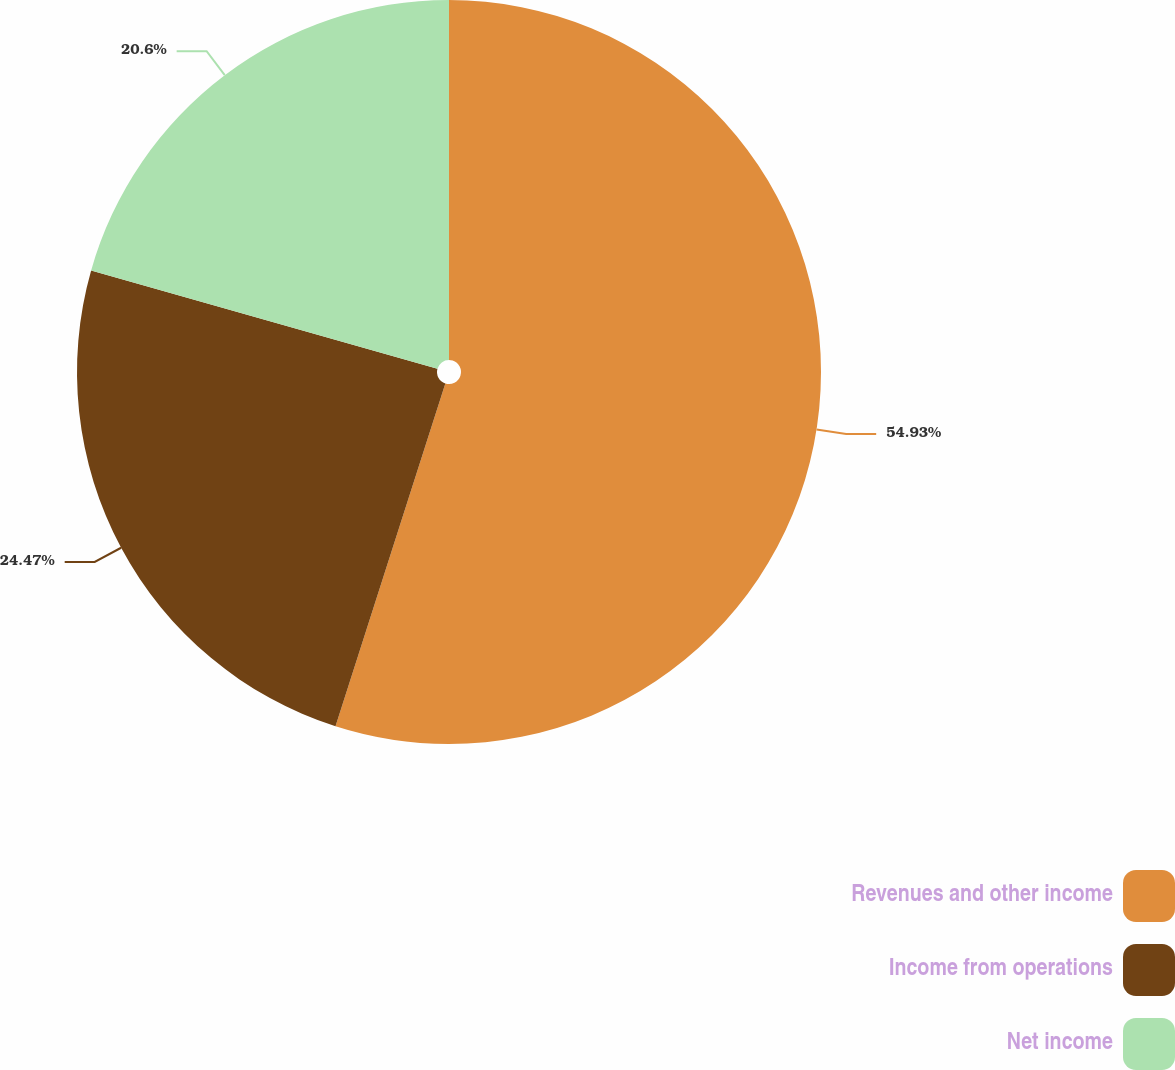Convert chart. <chart><loc_0><loc_0><loc_500><loc_500><pie_chart><fcel>Revenues and other income<fcel>Income from operations<fcel>Net income<nl><fcel>54.94%<fcel>24.47%<fcel>20.6%<nl></chart> 